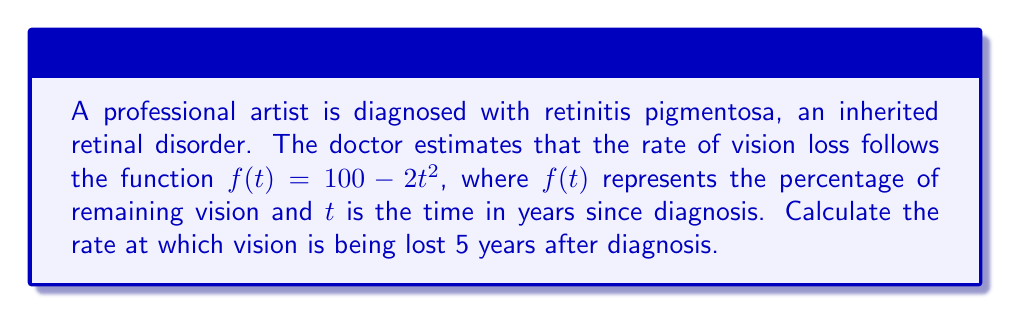Can you solve this math problem? To solve this problem, we need to find the derivative of the given function and evaluate it at $t=5$. Here's the step-by-step process:

1) The given function is $f(t) = 100 - 2t^2$

2) To find the rate of change, we need to calculate the derivative $f'(t)$:
   $$f'(t) = \frac{d}{dt}(100 - 2t^2)$$
   $$f'(t) = 0 - 2 \cdot 2t$$
   $$f'(t) = -4t$$

3) The derivative $f'(t) = -4t$ represents the instantaneous rate of change of vision with respect to time.

4) To find the rate of vision loss 5 years after diagnosis, we evaluate $f'(t)$ at $t=5$:
   $$f'(5) = -4(5) = -20$$

5) The negative sign indicates that vision is decreasing.

Therefore, 5 years after diagnosis, vision is being lost at a rate of 20 percentage points per year.
Answer: $-20$ percentage points per year 